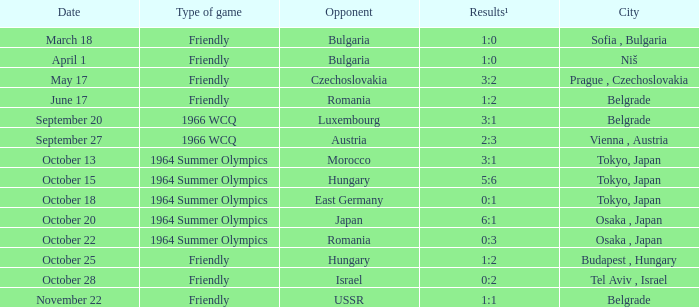Could you parse the entire table? {'header': ['Date', 'Type of game', 'Opponent', 'Results¹', 'City'], 'rows': [['March 18', 'Friendly', 'Bulgaria', '1:0', 'Sofia , Bulgaria'], ['April 1', 'Friendly', 'Bulgaria', '1:0', 'Niš'], ['May 17', 'Friendly', 'Czechoslovakia', '3:2', 'Prague , Czechoslovakia'], ['June 17', 'Friendly', 'Romania', '1:2', 'Belgrade'], ['September 20', '1966 WCQ', 'Luxembourg', '3:1', 'Belgrade'], ['September 27', '1966 WCQ', 'Austria', '2:3', 'Vienna , Austria'], ['October 13', '1964 Summer Olympics', 'Morocco', '3:1', 'Tokyo, Japan'], ['October 15', '1964 Summer Olympics', 'Hungary', '5:6', 'Tokyo, Japan'], ['October 18', '1964 Summer Olympics', 'East Germany', '0:1', 'Tokyo, Japan'], ['October 20', '1964 Summer Olympics', 'Japan', '6:1', 'Osaka , Japan'], ['October 22', '1964 Summer Olympics', 'Romania', '0:3', 'Osaka , Japan'], ['October 25', 'Friendly', 'Hungary', '1:2', 'Budapest , Hungary'], ['October 28', 'Friendly', 'Israel', '0:2', 'Tel Aviv , Israel'], ['November 22', 'Friendly', 'USSR', '1:1', 'Belgrade']]} What occurred during the 1964 summer olympics on october 18? 0:1. 